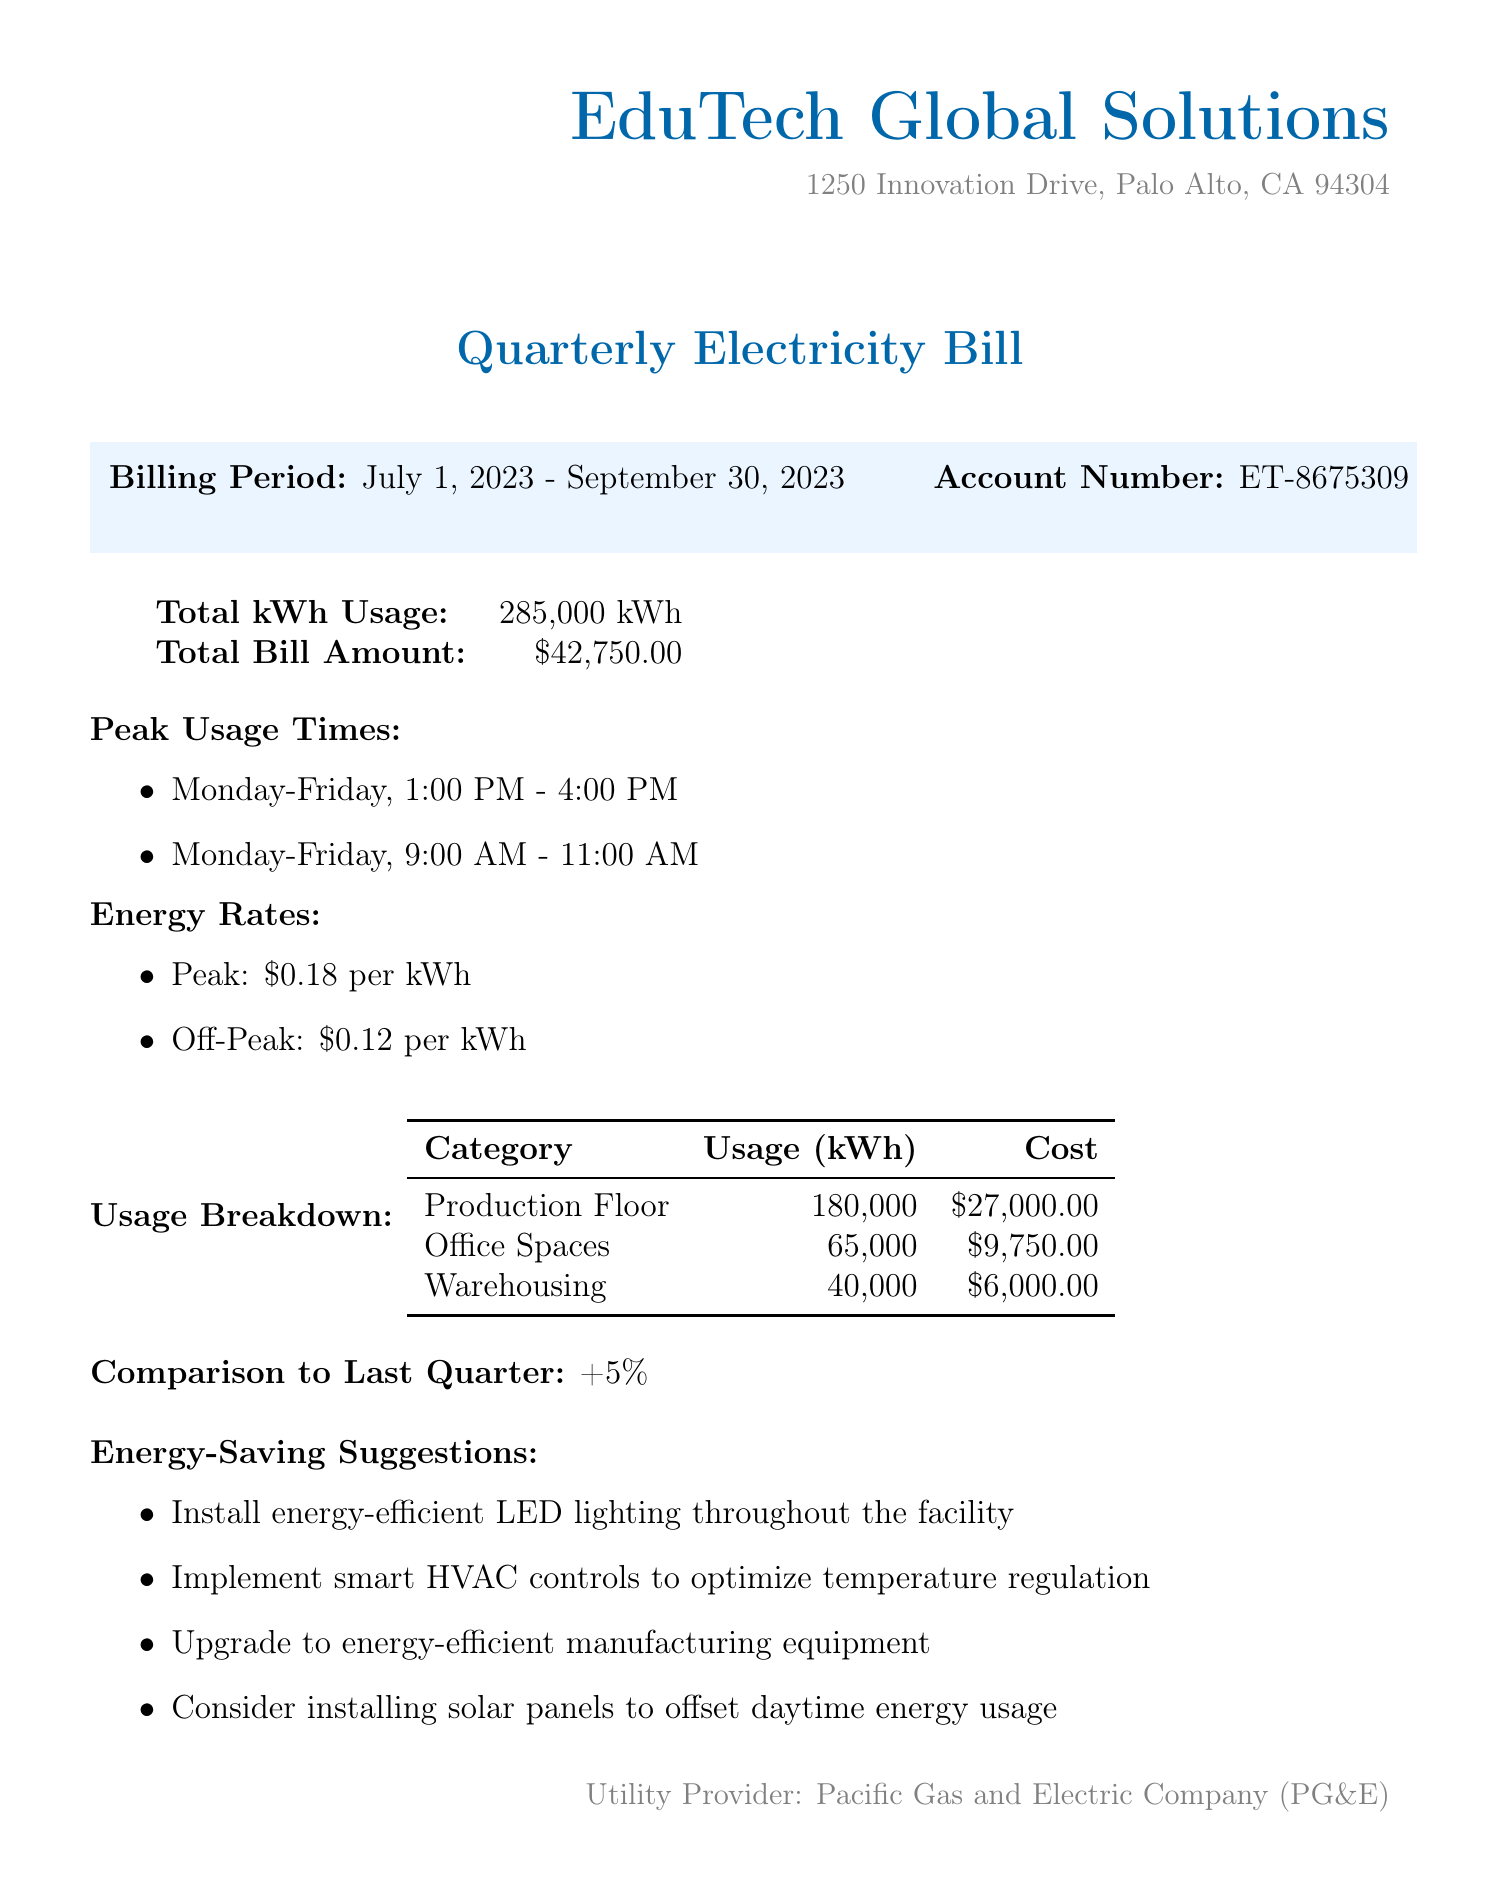what is the total kWh usage? The total kWh usage is clearly stated in the document under "Total kWh Usage".
Answer: 285,000 kWh what is the total bill amount? The total bill amount is listed in the document under "Total Bill Amount".
Answer: $42,750.00 what are the peak usage times? The peak usage times are provided in the section titled "Peak Usage Times".
Answer: Monday-Friday, 1:00 PM - 4:00 PM and Monday-Friday, 9:00 AM - 11:00 AM what is the energy rate during peak hours? The document specifies the energy rate during peak hours under “Energy Rates”.
Answer: $0.18 per kWh how much power is used on the Production Floor? The Usage Breakdown table shows the specific kWh usage for each category.
Answer: 180,000 kWh what is the percentage change in usage compared to last quarter? The comparison to last quarter is summarized in the section labeled "Comparison to Last Quarter".
Answer: +5% what energy-saving measure involves lighting? The suggested energy-saving measures include various methods, one of which is related to lighting.
Answer: Install energy-efficient LED lighting throughout the facility which utility provider is mentioned in the document? The document ends with information regarding the utility provider, which is located at the bottom of the page.
Answer: Pacific Gas and Electric Company (PG&E) what is the cost associated with Office Spaces usage? The cost associated with Office Spaces is detailed in the Usage Breakdown table.
Answer: $9,750.00 what is one suggestion for optimizing temperature? The energy-saving suggestions provide recommendations, one related to temperature optimization.
Answer: Implement smart HVAC controls to optimize temperature regulation 